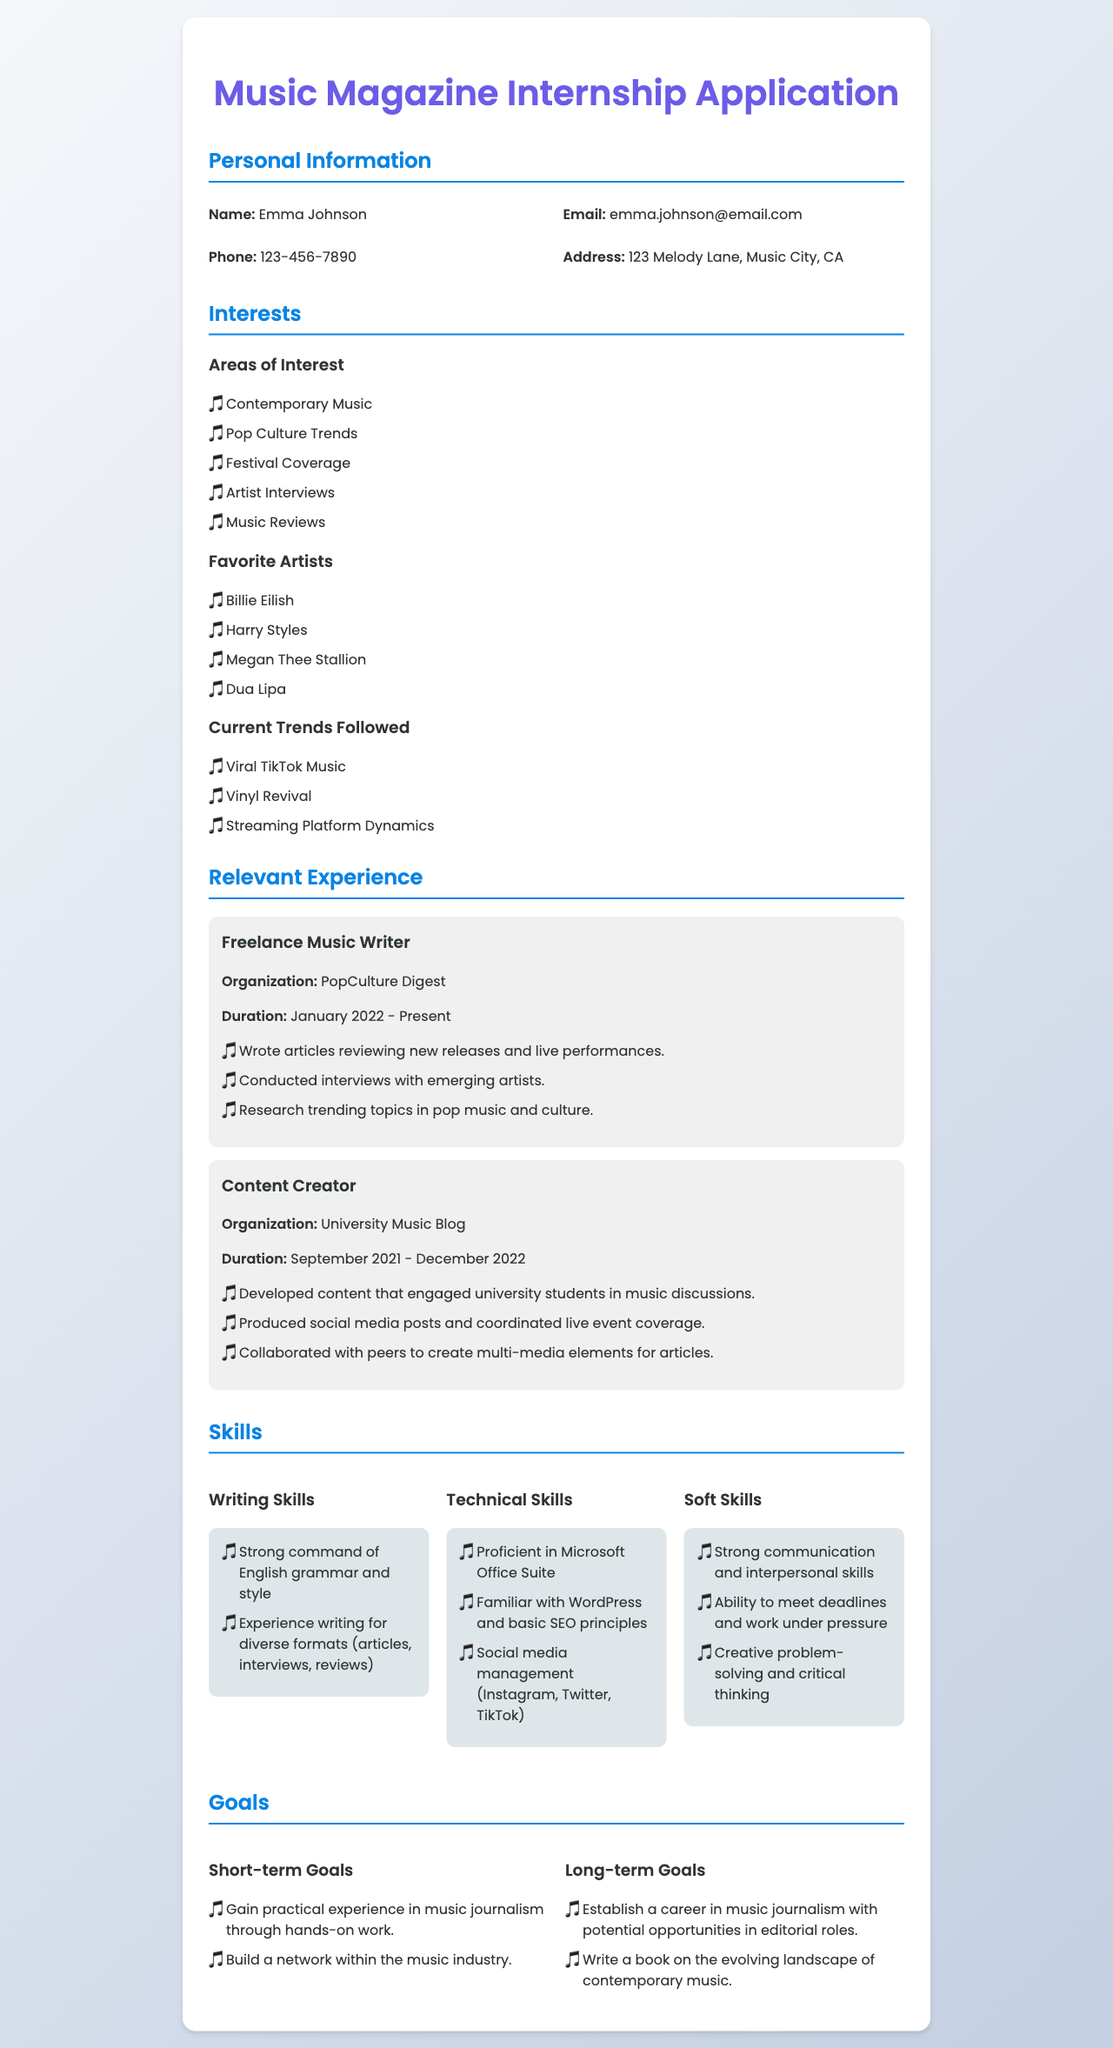What is the applicant's name? The applicant's name is listed under the personal information section of the document.
Answer: Emma Johnson What organization did the applicant work for as a Freelance Music Writer? The organization for the relevant experience of Freelance Music Writer is specifically mentioned in that section of the document.
Answer: PopCulture Digest What is one of the applicant's favorite artists? The document lists several favorite artists under the 'Favorite Artists' section.
Answer: Billie Eilish In which month and year did the applicant start working at PopCulture Digest? The start date is specified in the 'Relevant Experience' section for the role of Freelance Music Writer.
Answer: January 2022 What is one of the applicant's short-term goals? Short-term goals are described in the 'Goals' section of the document, listing aspirations for the near future.
Answer: Gain practical experience in music journalism through hands-on work How many skills categories are listed in the document? The skills section is divided into specific categories that are outlined in the document.
Answer: Three What type of content did the applicant create for the University Music Blog? The document provides specific examples of the work completed during the applicant's role at the University Music Blog.
Answer: Developed content that engaged university students in music discussions What current trend is the applicant following? Current trends are noted under the 'Current Trends Followed' section of the document.
Answer: Viral TikTok Music What are the applicant's long-term goals? The long-term goals are detailed in a section that outlines future aspirations and career objectives.
Answer: Establish a career in music journalism with potential opportunities in editorial roles 